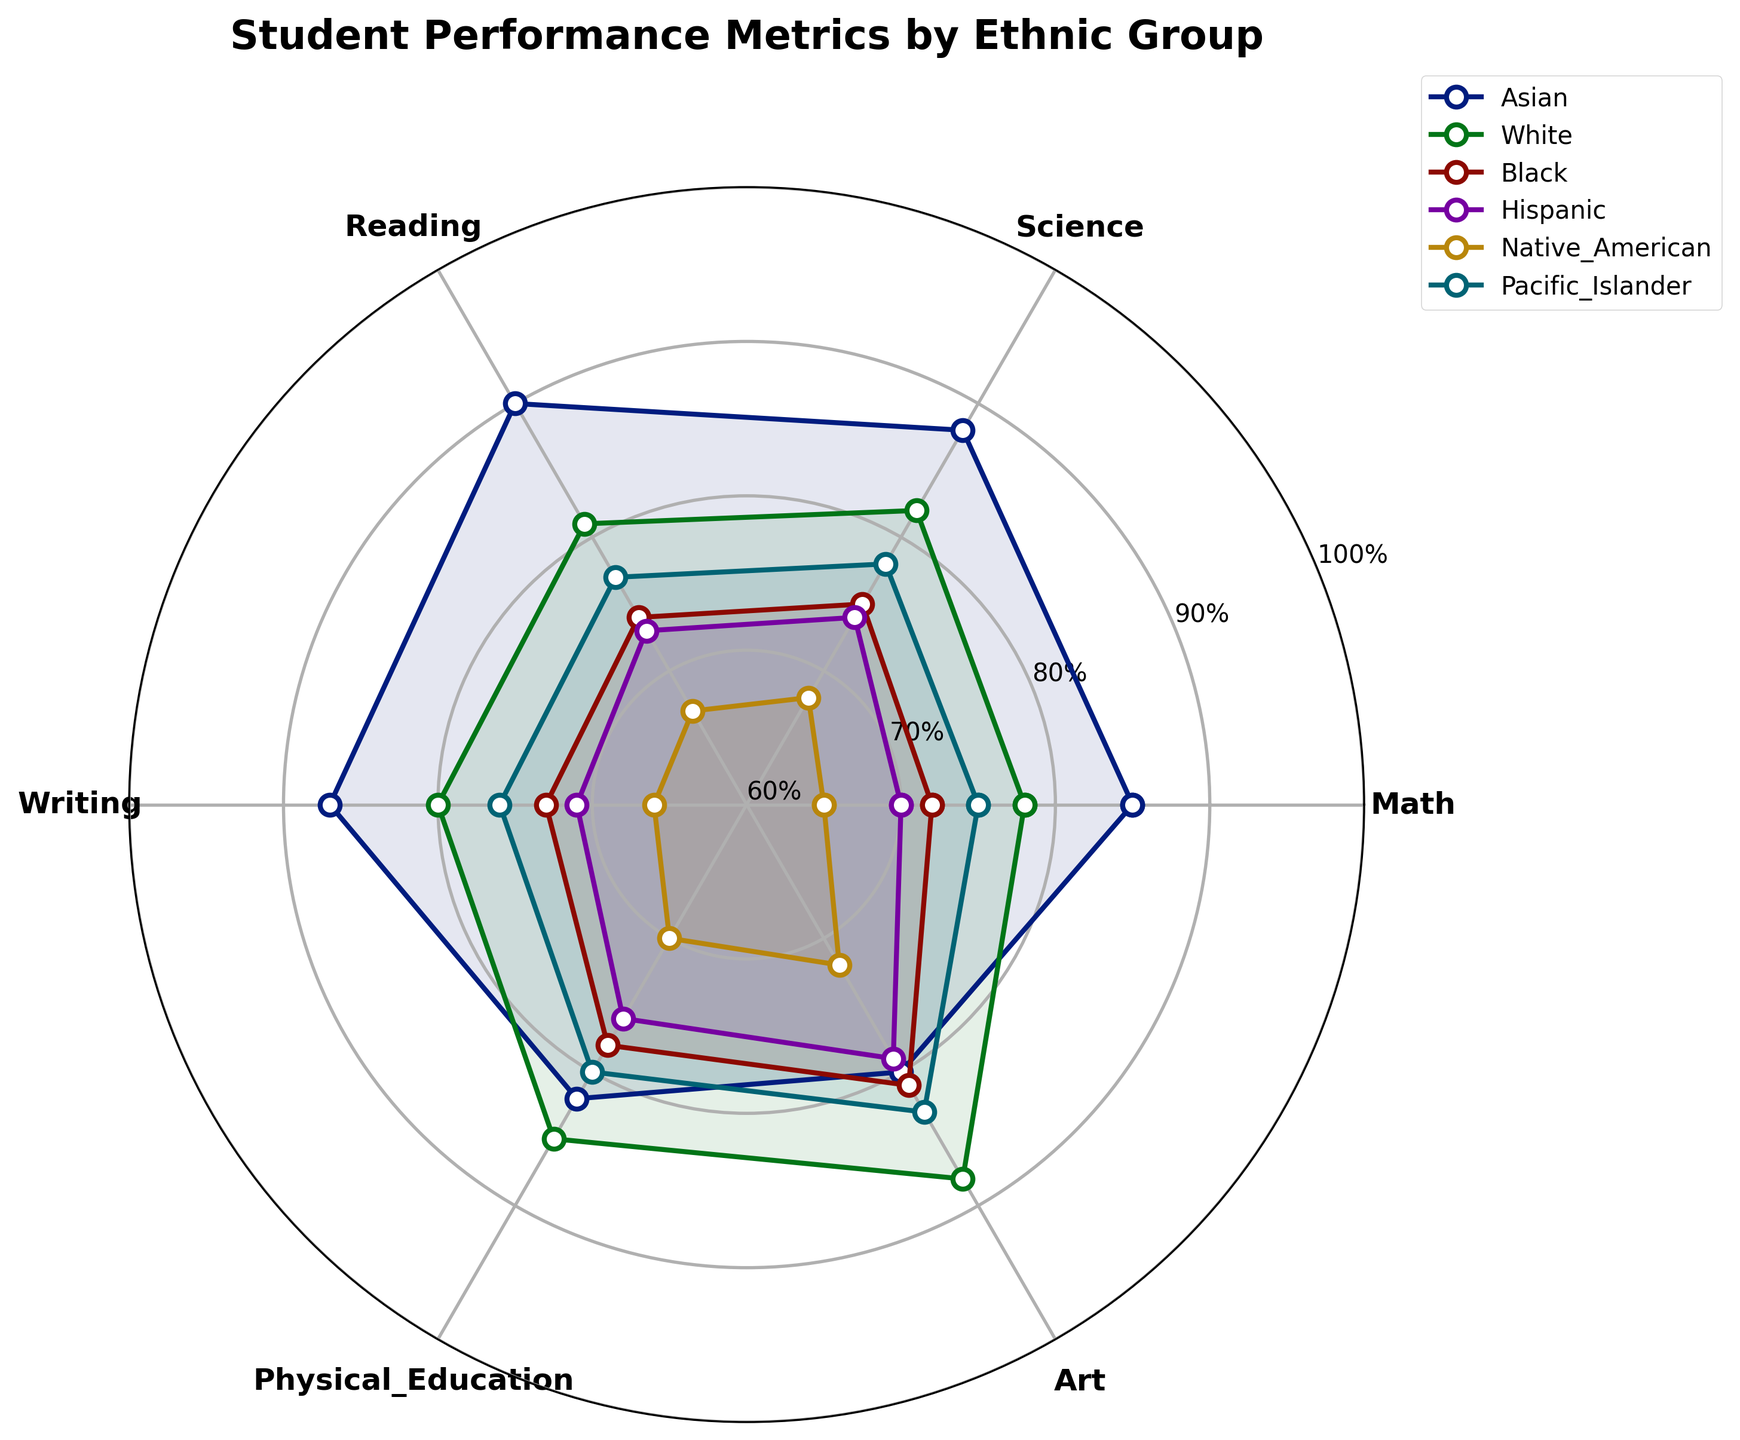What is the title of the figure? The title of the figure can be found at the top of the radar chart. It usually summarizes the main topic or purpose of the chart.
Answer: Student Performance Metrics by Ethnic Group How many categories are used to measure student performance? We can count the number of category labels around the chart to determine the number of performance metrics being measured.
Answer: 6 Which ethnic group has the highest score in Reading? By looking at the points around the Reading axis and comparing the values of different groups, we can identify which group has the highest score.
Answer: Asian What is the range of Physical Education scores across all groups? To find the range, we need to identify the maximum and minimum scores in Physical Education by checking the values around the corresponding axis: 85 (White) and 70 (Native American). The range is the difference between these two values.
Answer: 15 Which two ethnic groups have the most similar scores across all categories? We can visually inspect the radar chart and see which two groups have plots that look most similar, indicating similar scores across categories.
Answer: White and Pacific Islander What is the median score for the Writing category? To find the median score, first arrange the Writing scores in ascending order (66, 71, 73, 80, 87). With six scores, the median will be the average of the 3rd and 4th values.
Answer: 72 What is the average Math score across all ethnic groups? We find the average score by summing all Math scores and dividing by the number of groups: (85 + 78 + 72 + 70 + 65 + 75) = 445. So, the average is 445 / 6.
Answer: 74.17 Which category has the most balanced performance across all ethnic groups? A balanced performance would mean that scores are relatively close together. We compare the spread (range) of scores across each category to determine this.
Answer: Art Which ethnic group has the most consistent performance (smallest range between highest and lowest scores) across categories? Calculate the range for each group by finding the difference between their highest and lowest scores, then compare these ranges.
Answer: White Which category exhibits the greatest disparity in scores between groups? To determine the category with the greatest disparity, find the gap between the highest and lowest scores for each category and identify the largest gap.
Answer: Math 